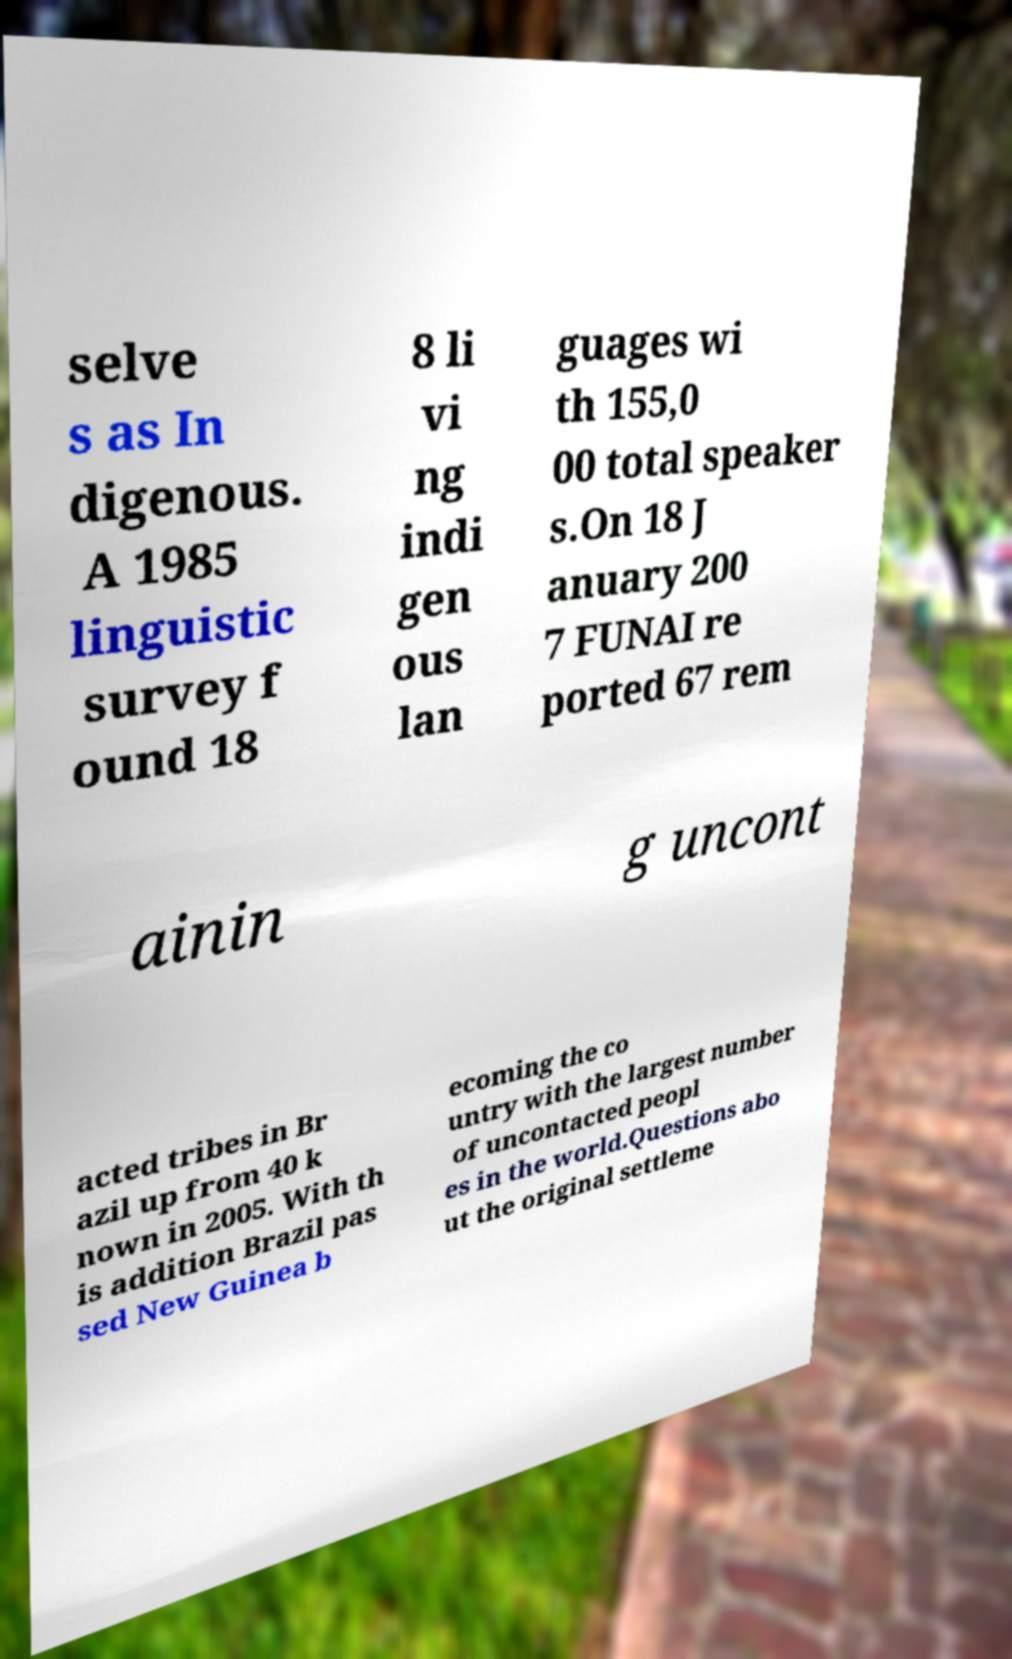There's text embedded in this image that I need extracted. Can you transcribe it verbatim? selve s as In digenous. A 1985 linguistic survey f ound 18 8 li vi ng indi gen ous lan guages wi th 155,0 00 total speaker s.On 18 J anuary 200 7 FUNAI re ported 67 rem ainin g uncont acted tribes in Br azil up from 40 k nown in 2005. With th is addition Brazil pas sed New Guinea b ecoming the co untry with the largest number of uncontacted peopl es in the world.Questions abo ut the original settleme 